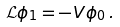Convert formula to latex. <formula><loc_0><loc_0><loc_500><loc_500>\mathcal { L } \phi _ { 1 } = - V \phi _ { 0 } \, .</formula> 